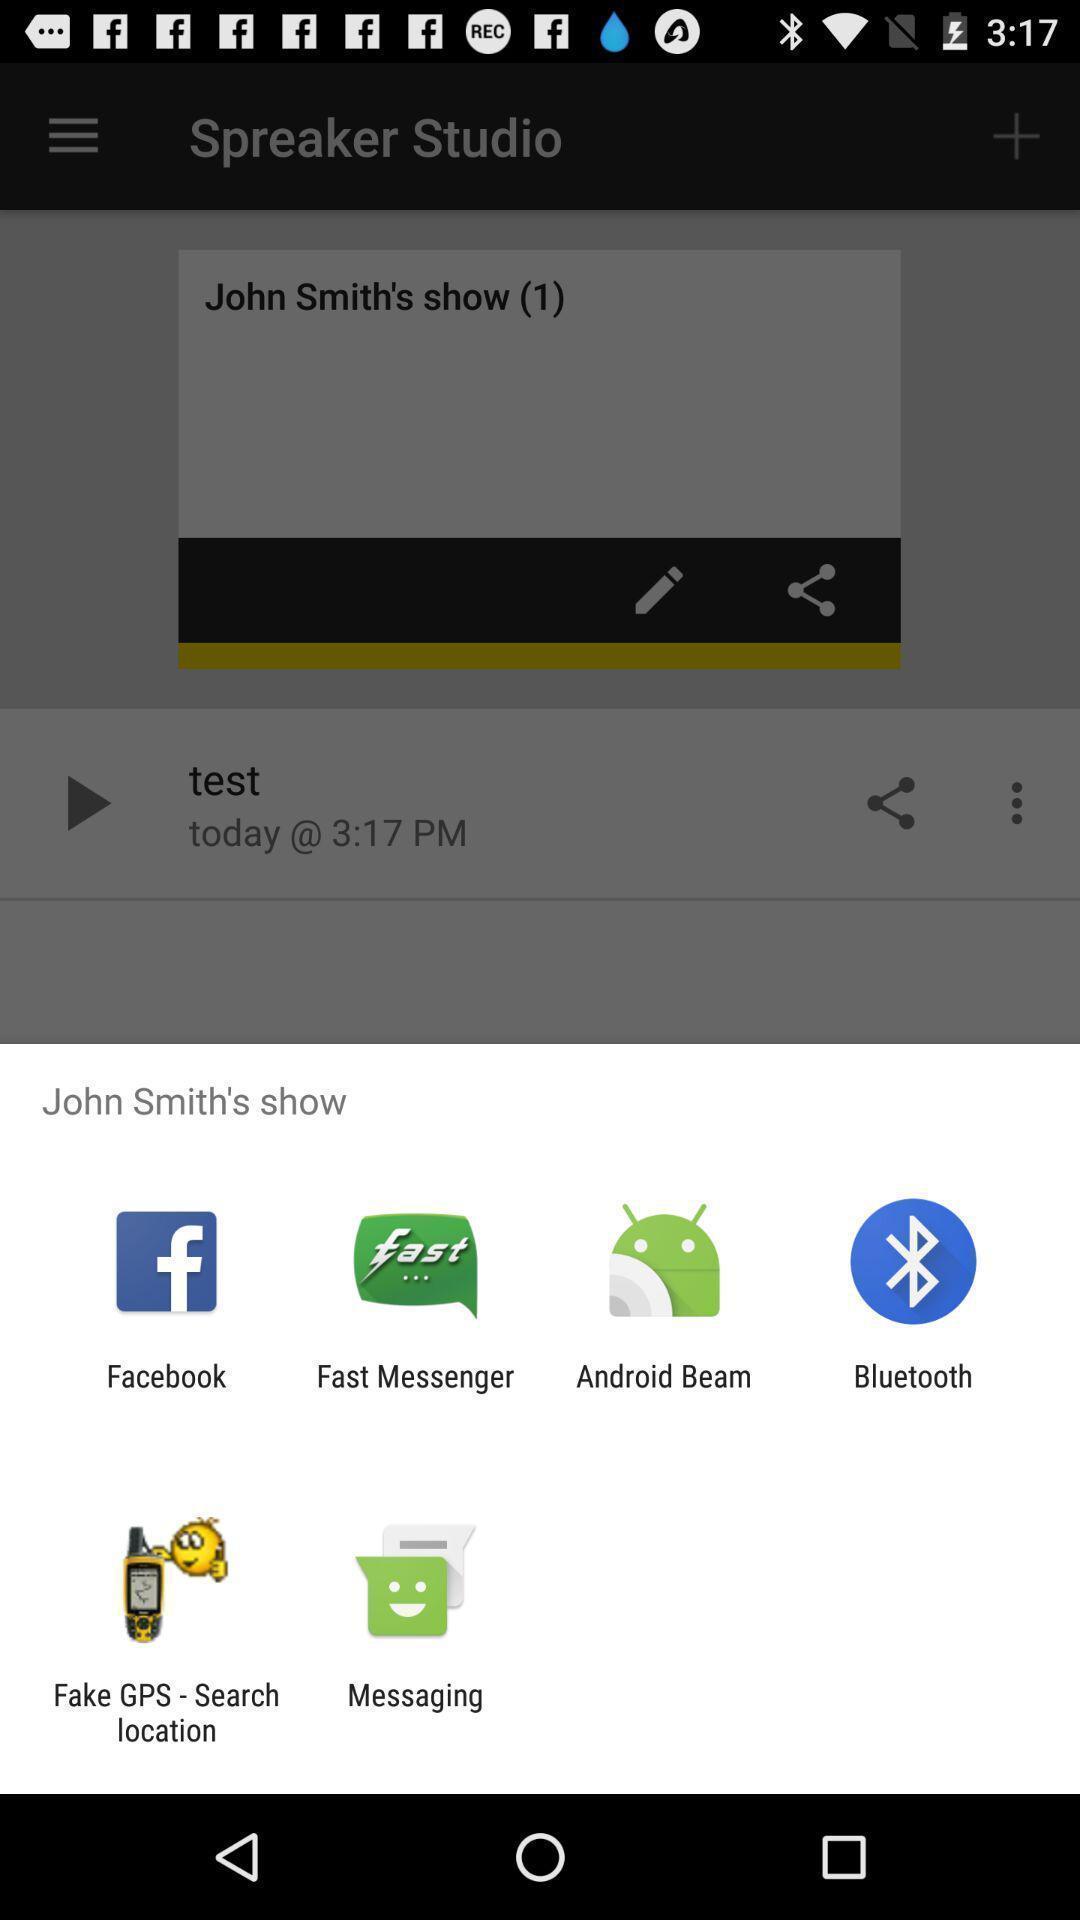Provide a description of this screenshot. Pop-up displaying various apps to share data. 